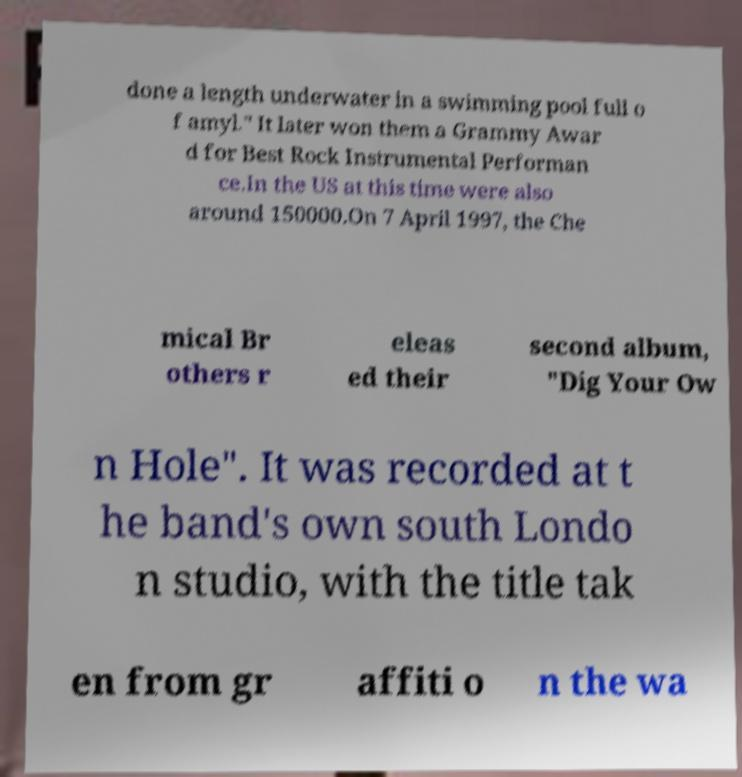Can you read and provide the text displayed in the image?This photo seems to have some interesting text. Can you extract and type it out for me? done a length underwater in a swimming pool full o f amyl." It later won them a Grammy Awar d for Best Rock Instrumental Performan ce.In the US at this time were also around 150000.On 7 April 1997, the Che mical Br others r eleas ed their second album, "Dig Your Ow n Hole". It was recorded at t he band's own south Londo n studio, with the title tak en from gr affiti o n the wa 